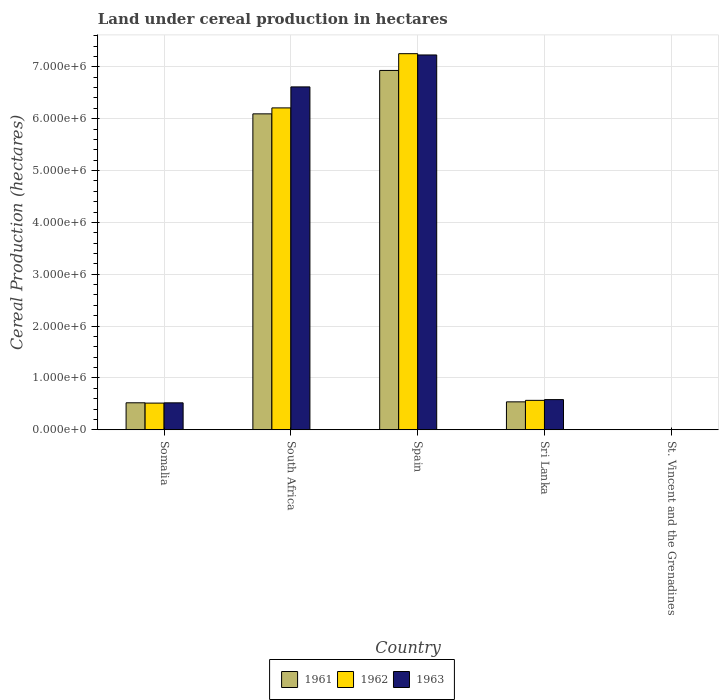How many groups of bars are there?
Provide a short and direct response. 5. Are the number of bars on each tick of the X-axis equal?
Offer a very short reply. Yes. How many bars are there on the 2nd tick from the left?
Your response must be concise. 3. What is the label of the 1st group of bars from the left?
Your answer should be very brief. Somalia. In how many cases, is the number of bars for a given country not equal to the number of legend labels?
Offer a very short reply. 0. What is the land under cereal production in 1962 in Somalia?
Your response must be concise. 5.15e+05. Across all countries, what is the maximum land under cereal production in 1962?
Give a very brief answer. 7.25e+06. Across all countries, what is the minimum land under cereal production in 1961?
Offer a very short reply. 100. In which country was the land under cereal production in 1962 maximum?
Offer a terse response. Spain. In which country was the land under cereal production in 1961 minimum?
Give a very brief answer. St. Vincent and the Grenadines. What is the total land under cereal production in 1961 in the graph?
Your answer should be compact. 1.41e+07. What is the difference between the land under cereal production in 1961 in Sri Lanka and that in St. Vincent and the Grenadines?
Your answer should be very brief. 5.39e+05. What is the difference between the land under cereal production in 1961 in South Africa and the land under cereal production in 1962 in Spain?
Make the answer very short. -1.16e+06. What is the average land under cereal production in 1962 per country?
Give a very brief answer. 2.91e+06. What is the difference between the land under cereal production of/in 1963 and land under cereal production of/in 1961 in South Africa?
Make the answer very short. 5.20e+05. In how many countries, is the land under cereal production in 1961 greater than 2400000 hectares?
Provide a short and direct response. 2. What is the ratio of the land under cereal production in 1961 in Spain to that in St. Vincent and the Grenadines?
Ensure brevity in your answer.  6.93e+04. What is the difference between the highest and the second highest land under cereal production in 1963?
Provide a succinct answer. 6.65e+06. What is the difference between the highest and the lowest land under cereal production in 1963?
Keep it short and to the point. 7.23e+06. Is the sum of the land under cereal production in 1963 in South Africa and St. Vincent and the Grenadines greater than the maximum land under cereal production in 1962 across all countries?
Offer a very short reply. No. Is it the case that in every country, the sum of the land under cereal production in 1962 and land under cereal production in 1961 is greater than the land under cereal production in 1963?
Provide a succinct answer. Yes. How many bars are there?
Your answer should be very brief. 15. How many countries are there in the graph?
Provide a succinct answer. 5. Does the graph contain grids?
Your answer should be very brief. Yes. How many legend labels are there?
Offer a very short reply. 3. How are the legend labels stacked?
Provide a short and direct response. Horizontal. What is the title of the graph?
Provide a succinct answer. Land under cereal production in hectares. What is the label or title of the Y-axis?
Offer a terse response. Cereal Production (hectares). What is the Cereal Production (hectares) of 1961 in Somalia?
Your response must be concise. 5.21e+05. What is the Cereal Production (hectares) in 1962 in Somalia?
Give a very brief answer. 5.15e+05. What is the Cereal Production (hectares) of 1963 in Somalia?
Ensure brevity in your answer.  5.20e+05. What is the Cereal Production (hectares) of 1961 in South Africa?
Your answer should be very brief. 6.09e+06. What is the Cereal Production (hectares) of 1962 in South Africa?
Your answer should be very brief. 6.21e+06. What is the Cereal Production (hectares) in 1963 in South Africa?
Give a very brief answer. 6.61e+06. What is the Cereal Production (hectares) in 1961 in Spain?
Make the answer very short. 6.93e+06. What is the Cereal Production (hectares) in 1962 in Spain?
Your response must be concise. 7.25e+06. What is the Cereal Production (hectares) in 1963 in Spain?
Make the answer very short. 7.23e+06. What is the Cereal Production (hectares) of 1961 in Sri Lanka?
Offer a terse response. 5.39e+05. What is the Cereal Production (hectares) of 1962 in Sri Lanka?
Provide a succinct answer. 5.68e+05. What is the Cereal Production (hectares) in 1963 in Sri Lanka?
Make the answer very short. 5.82e+05. What is the Cereal Production (hectares) of 1962 in St. Vincent and the Grenadines?
Your response must be concise. 100. What is the Cereal Production (hectares) of 1963 in St. Vincent and the Grenadines?
Keep it short and to the point. 100. Across all countries, what is the maximum Cereal Production (hectares) in 1961?
Give a very brief answer. 6.93e+06. Across all countries, what is the maximum Cereal Production (hectares) of 1962?
Ensure brevity in your answer.  7.25e+06. Across all countries, what is the maximum Cereal Production (hectares) in 1963?
Keep it short and to the point. 7.23e+06. Across all countries, what is the minimum Cereal Production (hectares) in 1961?
Your answer should be very brief. 100. Across all countries, what is the minimum Cereal Production (hectares) in 1962?
Give a very brief answer. 100. Across all countries, what is the minimum Cereal Production (hectares) of 1963?
Give a very brief answer. 100. What is the total Cereal Production (hectares) of 1961 in the graph?
Give a very brief answer. 1.41e+07. What is the total Cereal Production (hectares) of 1962 in the graph?
Offer a terse response. 1.45e+07. What is the total Cereal Production (hectares) in 1963 in the graph?
Give a very brief answer. 1.49e+07. What is the difference between the Cereal Production (hectares) in 1961 in Somalia and that in South Africa?
Offer a very short reply. -5.57e+06. What is the difference between the Cereal Production (hectares) of 1962 in Somalia and that in South Africa?
Your response must be concise. -5.69e+06. What is the difference between the Cereal Production (hectares) in 1963 in Somalia and that in South Africa?
Give a very brief answer. -6.09e+06. What is the difference between the Cereal Production (hectares) in 1961 in Somalia and that in Spain?
Keep it short and to the point. -6.41e+06. What is the difference between the Cereal Production (hectares) of 1962 in Somalia and that in Spain?
Your response must be concise. -6.74e+06. What is the difference between the Cereal Production (hectares) in 1963 in Somalia and that in Spain?
Ensure brevity in your answer.  -6.71e+06. What is the difference between the Cereal Production (hectares) of 1961 in Somalia and that in Sri Lanka?
Make the answer very short. -1.82e+04. What is the difference between the Cereal Production (hectares) in 1962 in Somalia and that in Sri Lanka?
Keep it short and to the point. -5.31e+04. What is the difference between the Cereal Production (hectares) in 1963 in Somalia and that in Sri Lanka?
Your response must be concise. -6.25e+04. What is the difference between the Cereal Production (hectares) in 1961 in Somalia and that in St. Vincent and the Grenadines?
Your answer should be very brief. 5.21e+05. What is the difference between the Cereal Production (hectares) of 1962 in Somalia and that in St. Vincent and the Grenadines?
Provide a short and direct response. 5.15e+05. What is the difference between the Cereal Production (hectares) of 1963 in Somalia and that in St. Vincent and the Grenadines?
Your answer should be very brief. 5.20e+05. What is the difference between the Cereal Production (hectares) of 1961 in South Africa and that in Spain?
Provide a short and direct response. -8.37e+05. What is the difference between the Cereal Production (hectares) of 1962 in South Africa and that in Spain?
Provide a succinct answer. -1.05e+06. What is the difference between the Cereal Production (hectares) of 1963 in South Africa and that in Spain?
Your answer should be very brief. -6.16e+05. What is the difference between the Cereal Production (hectares) in 1961 in South Africa and that in Sri Lanka?
Provide a short and direct response. 5.55e+06. What is the difference between the Cereal Production (hectares) in 1962 in South Africa and that in Sri Lanka?
Your answer should be compact. 5.64e+06. What is the difference between the Cereal Production (hectares) of 1963 in South Africa and that in Sri Lanka?
Make the answer very short. 6.03e+06. What is the difference between the Cereal Production (hectares) in 1961 in South Africa and that in St. Vincent and the Grenadines?
Your answer should be compact. 6.09e+06. What is the difference between the Cereal Production (hectares) in 1962 in South Africa and that in St. Vincent and the Grenadines?
Give a very brief answer. 6.21e+06. What is the difference between the Cereal Production (hectares) in 1963 in South Africa and that in St. Vincent and the Grenadines?
Provide a succinct answer. 6.61e+06. What is the difference between the Cereal Production (hectares) of 1961 in Spain and that in Sri Lanka?
Provide a short and direct response. 6.39e+06. What is the difference between the Cereal Production (hectares) of 1962 in Spain and that in Sri Lanka?
Make the answer very short. 6.68e+06. What is the difference between the Cereal Production (hectares) in 1963 in Spain and that in Sri Lanka?
Your answer should be very brief. 6.65e+06. What is the difference between the Cereal Production (hectares) of 1961 in Spain and that in St. Vincent and the Grenadines?
Offer a terse response. 6.93e+06. What is the difference between the Cereal Production (hectares) in 1962 in Spain and that in St. Vincent and the Grenadines?
Offer a very short reply. 7.25e+06. What is the difference between the Cereal Production (hectares) in 1963 in Spain and that in St. Vincent and the Grenadines?
Offer a terse response. 7.23e+06. What is the difference between the Cereal Production (hectares) of 1961 in Sri Lanka and that in St. Vincent and the Grenadines?
Provide a short and direct response. 5.39e+05. What is the difference between the Cereal Production (hectares) of 1962 in Sri Lanka and that in St. Vincent and the Grenadines?
Offer a terse response. 5.68e+05. What is the difference between the Cereal Production (hectares) in 1963 in Sri Lanka and that in St. Vincent and the Grenadines?
Provide a short and direct response. 5.82e+05. What is the difference between the Cereal Production (hectares) in 1961 in Somalia and the Cereal Production (hectares) in 1962 in South Africa?
Your answer should be compact. -5.69e+06. What is the difference between the Cereal Production (hectares) of 1961 in Somalia and the Cereal Production (hectares) of 1963 in South Africa?
Offer a very short reply. -6.09e+06. What is the difference between the Cereal Production (hectares) in 1962 in Somalia and the Cereal Production (hectares) in 1963 in South Africa?
Give a very brief answer. -6.10e+06. What is the difference between the Cereal Production (hectares) of 1961 in Somalia and the Cereal Production (hectares) of 1962 in Spain?
Ensure brevity in your answer.  -6.73e+06. What is the difference between the Cereal Production (hectares) in 1961 in Somalia and the Cereal Production (hectares) in 1963 in Spain?
Your response must be concise. -6.71e+06. What is the difference between the Cereal Production (hectares) in 1962 in Somalia and the Cereal Production (hectares) in 1963 in Spain?
Ensure brevity in your answer.  -6.71e+06. What is the difference between the Cereal Production (hectares) in 1961 in Somalia and the Cereal Production (hectares) in 1962 in Sri Lanka?
Give a very brief answer. -4.71e+04. What is the difference between the Cereal Production (hectares) of 1961 in Somalia and the Cereal Production (hectares) of 1963 in Sri Lanka?
Provide a succinct answer. -6.15e+04. What is the difference between the Cereal Production (hectares) of 1962 in Somalia and the Cereal Production (hectares) of 1963 in Sri Lanka?
Make the answer very short. -6.75e+04. What is the difference between the Cereal Production (hectares) of 1961 in Somalia and the Cereal Production (hectares) of 1962 in St. Vincent and the Grenadines?
Your answer should be very brief. 5.21e+05. What is the difference between the Cereal Production (hectares) of 1961 in Somalia and the Cereal Production (hectares) of 1963 in St. Vincent and the Grenadines?
Your response must be concise. 5.21e+05. What is the difference between the Cereal Production (hectares) in 1962 in Somalia and the Cereal Production (hectares) in 1963 in St. Vincent and the Grenadines?
Provide a short and direct response. 5.15e+05. What is the difference between the Cereal Production (hectares) of 1961 in South Africa and the Cereal Production (hectares) of 1962 in Spain?
Your response must be concise. -1.16e+06. What is the difference between the Cereal Production (hectares) in 1961 in South Africa and the Cereal Production (hectares) in 1963 in Spain?
Ensure brevity in your answer.  -1.14e+06. What is the difference between the Cereal Production (hectares) in 1962 in South Africa and the Cereal Production (hectares) in 1963 in Spain?
Provide a short and direct response. -1.02e+06. What is the difference between the Cereal Production (hectares) in 1961 in South Africa and the Cereal Production (hectares) in 1962 in Sri Lanka?
Your answer should be compact. 5.52e+06. What is the difference between the Cereal Production (hectares) in 1961 in South Africa and the Cereal Production (hectares) in 1963 in Sri Lanka?
Keep it short and to the point. 5.51e+06. What is the difference between the Cereal Production (hectares) of 1962 in South Africa and the Cereal Production (hectares) of 1963 in Sri Lanka?
Your answer should be compact. 5.63e+06. What is the difference between the Cereal Production (hectares) of 1961 in South Africa and the Cereal Production (hectares) of 1962 in St. Vincent and the Grenadines?
Make the answer very short. 6.09e+06. What is the difference between the Cereal Production (hectares) of 1961 in South Africa and the Cereal Production (hectares) of 1963 in St. Vincent and the Grenadines?
Your answer should be very brief. 6.09e+06. What is the difference between the Cereal Production (hectares) of 1962 in South Africa and the Cereal Production (hectares) of 1963 in St. Vincent and the Grenadines?
Provide a short and direct response. 6.21e+06. What is the difference between the Cereal Production (hectares) of 1961 in Spain and the Cereal Production (hectares) of 1962 in Sri Lanka?
Provide a short and direct response. 6.36e+06. What is the difference between the Cereal Production (hectares) of 1961 in Spain and the Cereal Production (hectares) of 1963 in Sri Lanka?
Offer a terse response. 6.35e+06. What is the difference between the Cereal Production (hectares) of 1962 in Spain and the Cereal Production (hectares) of 1963 in Sri Lanka?
Provide a short and direct response. 6.67e+06. What is the difference between the Cereal Production (hectares) of 1961 in Spain and the Cereal Production (hectares) of 1962 in St. Vincent and the Grenadines?
Your answer should be compact. 6.93e+06. What is the difference between the Cereal Production (hectares) in 1961 in Spain and the Cereal Production (hectares) in 1963 in St. Vincent and the Grenadines?
Your response must be concise. 6.93e+06. What is the difference between the Cereal Production (hectares) in 1962 in Spain and the Cereal Production (hectares) in 1963 in St. Vincent and the Grenadines?
Your response must be concise. 7.25e+06. What is the difference between the Cereal Production (hectares) in 1961 in Sri Lanka and the Cereal Production (hectares) in 1962 in St. Vincent and the Grenadines?
Your answer should be very brief. 5.39e+05. What is the difference between the Cereal Production (hectares) of 1961 in Sri Lanka and the Cereal Production (hectares) of 1963 in St. Vincent and the Grenadines?
Make the answer very short. 5.39e+05. What is the difference between the Cereal Production (hectares) in 1962 in Sri Lanka and the Cereal Production (hectares) in 1963 in St. Vincent and the Grenadines?
Your answer should be compact. 5.68e+05. What is the average Cereal Production (hectares) of 1961 per country?
Keep it short and to the point. 2.82e+06. What is the average Cereal Production (hectares) in 1962 per country?
Provide a short and direct response. 2.91e+06. What is the average Cereal Production (hectares) of 1963 per country?
Offer a terse response. 2.99e+06. What is the difference between the Cereal Production (hectares) in 1961 and Cereal Production (hectares) in 1962 in Somalia?
Provide a succinct answer. 6000. What is the difference between the Cereal Production (hectares) in 1962 and Cereal Production (hectares) in 1963 in Somalia?
Make the answer very short. -5000. What is the difference between the Cereal Production (hectares) of 1961 and Cereal Production (hectares) of 1962 in South Africa?
Your answer should be compact. -1.15e+05. What is the difference between the Cereal Production (hectares) in 1961 and Cereal Production (hectares) in 1963 in South Africa?
Make the answer very short. -5.20e+05. What is the difference between the Cereal Production (hectares) in 1962 and Cereal Production (hectares) in 1963 in South Africa?
Offer a terse response. -4.05e+05. What is the difference between the Cereal Production (hectares) in 1961 and Cereal Production (hectares) in 1962 in Spain?
Provide a succinct answer. -3.23e+05. What is the difference between the Cereal Production (hectares) in 1961 and Cereal Production (hectares) in 1963 in Spain?
Your answer should be very brief. -2.99e+05. What is the difference between the Cereal Production (hectares) of 1962 and Cereal Production (hectares) of 1963 in Spain?
Your answer should be compact. 2.46e+04. What is the difference between the Cereal Production (hectares) in 1961 and Cereal Production (hectares) in 1962 in Sri Lanka?
Provide a short and direct response. -2.89e+04. What is the difference between the Cereal Production (hectares) of 1961 and Cereal Production (hectares) of 1963 in Sri Lanka?
Keep it short and to the point. -4.33e+04. What is the difference between the Cereal Production (hectares) of 1962 and Cereal Production (hectares) of 1963 in Sri Lanka?
Make the answer very short. -1.44e+04. What is the difference between the Cereal Production (hectares) of 1961 and Cereal Production (hectares) of 1962 in St. Vincent and the Grenadines?
Ensure brevity in your answer.  0. What is the ratio of the Cereal Production (hectares) of 1961 in Somalia to that in South Africa?
Offer a terse response. 0.09. What is the ratio of the Cereal Production (hectares) in 1962 in Somalia to that in South Africa?
Offer a very short reply. 0.08. What is the ratio of the Cereal Production (hectares) in 1963 in Somalia to that in South Africa?
Give a very brief answer. 0.08. What is the ratio of the Cereal Production (hectares) of 1961 in Somalia to that in Spain?
Offer a very short reply. 0.08. What is the ratio of the Cereal Production (hectares) in 1962 in Somalia to that in Spain?
Your response must be concise. 0.07. What is the ratio of the Cereal Production (hectares) in 1963 in Somalia to that in Spain?
Your answer should be very brief. 0.07. What is the ratio of the Cereal Production (hectares) of 1961 in Somalia to that in Sri Lanka?
Give a very brief answer. 0.97. What is the ratio of the Cereal Production (hectares) of 1962 in Somalia to that in Sri Lanka?
Your answer should be very brief. 0.91. What is the ratio of the Cereal Production (hectares) of 1963 in Somalia to that in Sri Lanka?
Your response must be concise. 0.89. What is the ratio of the Cereal Production (hectares) of 1961 in Somalia to that in St. Vincent and the Grenadines?
Ensure brevity in your answer.  5210. What is the ratio of the Cereal Production (hectares) of 1962 in Somalia to that in St. Vincent and the Grenadines?
Give a very brief answer. 5150. What is the ratio of the Cereal Production (hectares) in 1963 in Somalia to that in St. Vincent and the Grenadines?
Your response must be concise. 5200. What is the ratio of the Cereal Production (hectares) of 1961 in South Africa to that in Spain?
Offer a terse response. 0.88. What is the ratio of the Cereal Production (hectares) of 1962 in South Africa to that in Spain?
Your answer should be compact. 0.86. What is the ratio of the Cereal Production (hectares) in 1963 in South Africa to that in Spain?
Ensure brevity in your answer.  0.91. What is the ratio of the Cereal Production (hectares) of 1961 in South Africa to that in Sri Lanka?
Keep it short and to the point. 11.3. What is the ratio of the Cereal Production (hectares) of 1962 in South Africa to that in Sri Lanka?
Your answer should be very brief. 10.93. What is the ratio of the Cereal Production (hectares) in 1963 in South Africa to that in Sri Lanka?
Keep it short and to the point. 11.35. What is the ratio of the Cereal Production (hectares) of 1961 in South Africa to that in St. Vincent and the Grenadines?
Provide a succinct answer. 6.09e+04. What is the ratio of the Cereal Production (hectares) in 1962 in South Africa to that in St. Vincent and the Grenadines?
Your answer should be very brief. 6.21e+04. What is the ratio of the Cereal Production (hectares) in 1963 in South Africa to that in St. Vincent and the Grenadines?
Offer a terse response. 6.61e+04. What is the ratio of the Cereal Production (hectares) in 1961 in Spain to that in Sri Lanka?
Give a very brief answer. 12.85. What is the ratio of the Cereal Production (hectares) in 1962 in Spain to that in Sri Lanka?
Ensure brevity in your answer.  12.77. What is the ratio of the Cereal Production (hectares) of 1963 in Spain to that in Sri Lanka?
Provide a succinct answer. 12.41. What is the ratio of the Cereal Production (hectares) in 1961 in Spain to that in St. Vincent and the Grenadines?
Provide a succinct answer. 6.93e+04. What is the ratio of the Cereal Production (hectares) in 1962 in Spain to that in St. Vincent and the Grenadines?
Offer a very short reply. 7.25e+04. What is the ratio of the Cereal Production (hectares) of 1963 in Spain to that in St. Vincent and the Grenadines?
Ensure brevity in your answer.  7.23e+04. What is the ratio of the Cereal Production (hectares) of 1961 in Sri Lanka to that in St. Vincent and the Grenadines?
Your answer should be very brief. 5391.71. What is the ratio of the Cereal Production (hectares) of 1962 in Sri Lanka to that in St. Vincent and the Grenadines?
Provide a succinct answer. 5680.96. What is the ratio of the Cereal Production (hectares) of 1963 in Sri Lanka to that in St. Vincent and the Grenadines?
Your response must be concise. 5824.57. What is the difference between the highest and the second highest Cereal Production (hectares) in 1961?
Provide a short and direct response. 8.37e+05. What is the difference between the highest and the second highest Cereal Production (hectares) in 1962?
Keep it short and to the point. 1.05e+06. What is the difference between the highest and the second highest Cereal Production (hectares) of 1963?
Your response must be concise. 6.16e+05. What is the difference between the highest and the lowest Cereal Production (hectares) of 1961?
Offer a very short reply. 6.93e+06. What is the difference between the highest and the lowest Cereal Production (hectares) in 1962?
Your response must be concise. 7.25e+06. What is the difference between the highest and the lowest Cereal Production (hectares) of 1963?
Provide a short and direct response. 7.23e+06. 